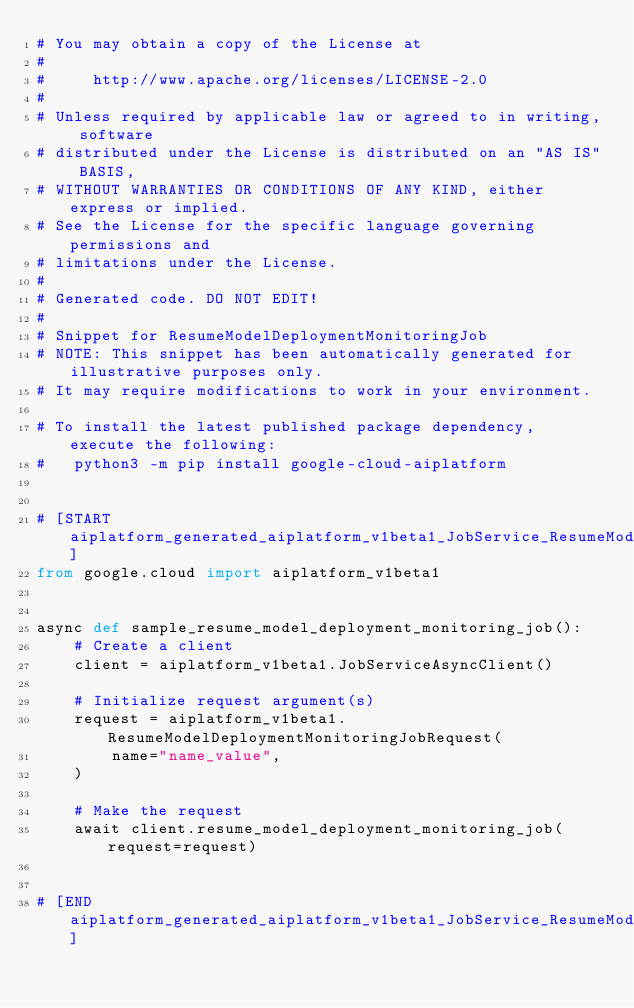Convert code to text. <code><loc_0><loc_0><loc_500><loc_500><_Python_># You may obtain a copy of the License at
#
#     http://www.apache.org/licenses/LICENSE-2.0
#
# Unless required by applicable law or agreed to in writing, software
# distributed under the License is distributed on an "AS IS" BASIS,
# WITHOUT WARRANTIES OR CONDITIONS OF ANY KIND, either express or implied.
# See the License for the specific language governing permissions and
# limitations under the License.
#
# Generated code. DO NOT EDIT!
#
# Snippet for ResumeModelDeploymentMonitoringJob
# NOTE: This snippet has been automatically generated for illustrative purposes only.
# It may require modifications to work in your environment.

# To install the latest published package dependency, execute the following:
#   python3 -m pip install google-cloud-aiplatform


# [START aiplatform_generated_aiplatform_v1beta1_JobService_ResumeModelDeploymentMonitoringJob_async]
from google.cloud import aiplatform_v1beta1


async def sample_resume_model_deployment_monitoring_job():
    # Create a client
    client = aiplatform_v1beta1.JobServiceAsyncClient()

    # Initialize request argument(s)
    request = aiplatform_v1beta1.ResumeModelDeploymentMonitoringJobRequest(
        name="name_value",
    )

    # Make the request
    await client.resume_model_deployment_monitoring_job(request=request)


# [END aiplatform_generated_aiplatform_v1beta1_JobService_ResumeModelDeploymentMonitoringJob_async]
</code> 